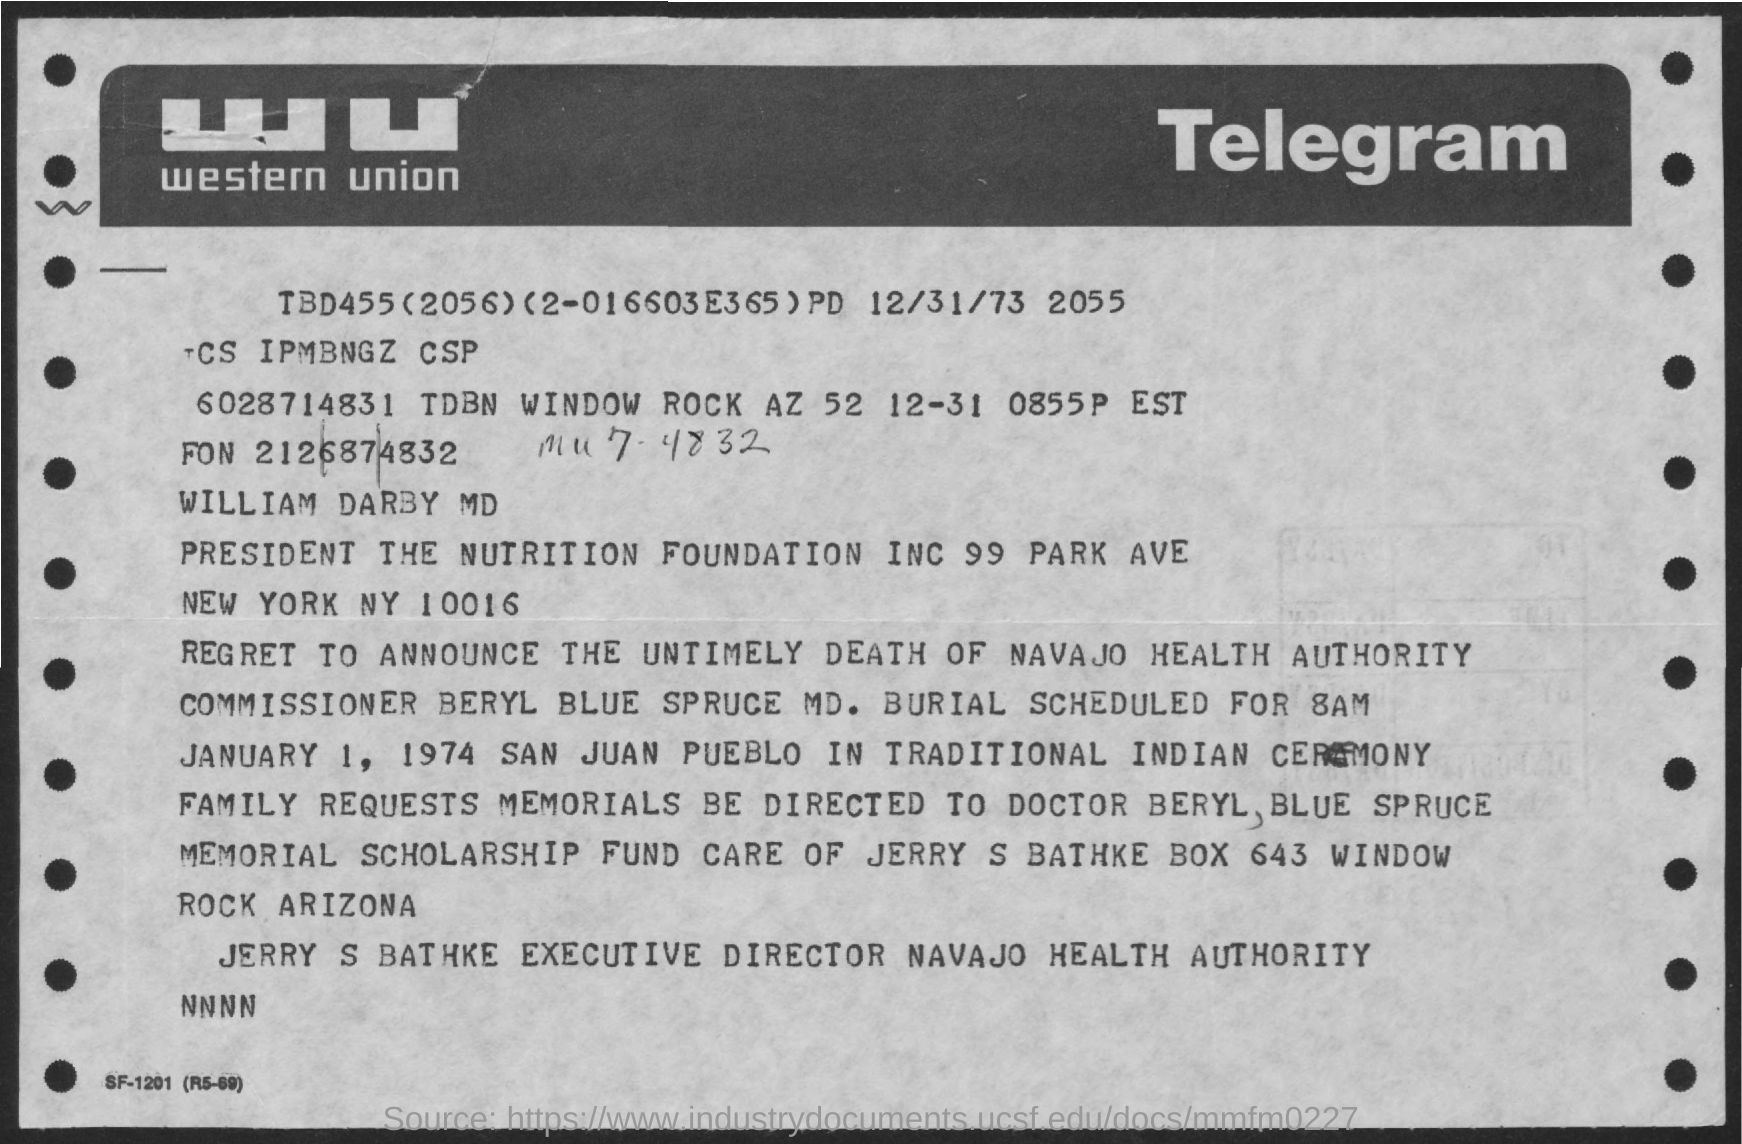Mention a couple of crucial points in this snapshot. Western Union is a company that provides financial services, and the full form of WU is an abbreviation commonly used to refer to this company. The Executive Director of Navajo Health Authority is Jerry S. Bathke. 